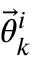<formula> <loc_0><loc_0><loc_500><loc_500>{ \vec { \theta } } _ { k } ^ { i }</formula> 